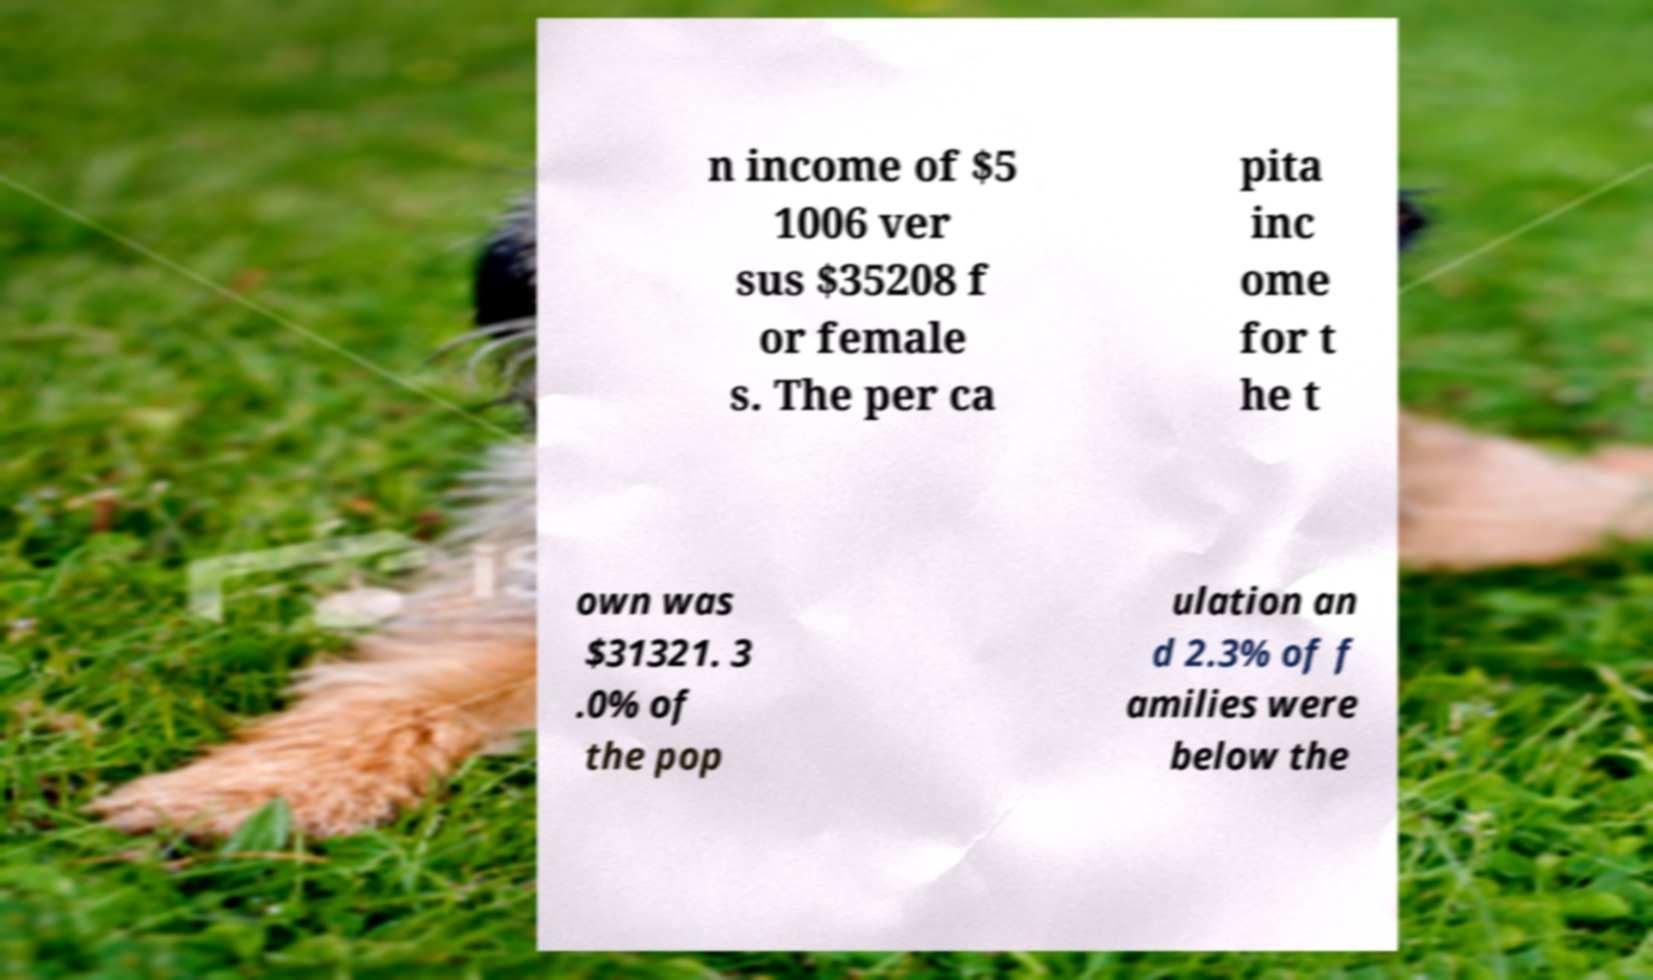Can you accurately transcribe the text from the provided image for me? n income of $5 1006 ver sus $35208 f or female s. The per ca pita inc ome for t he t own was $31321. 3 .0% of the pop ulation an d 2.3% of f amilies were below the 